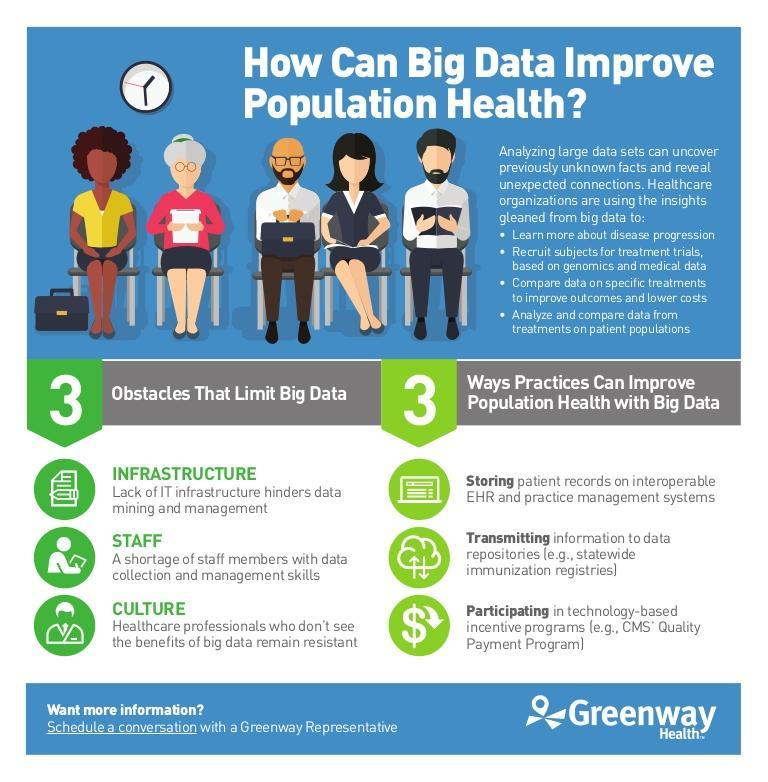How many types of activities are healthcare organistions able to do by using the insights gleaned from big data
Answer the question with a short phrase. 4 what is an eg. of data repositories statewide immunization registries What are the main obstacles that limit big data infrastructure, staff, culture 